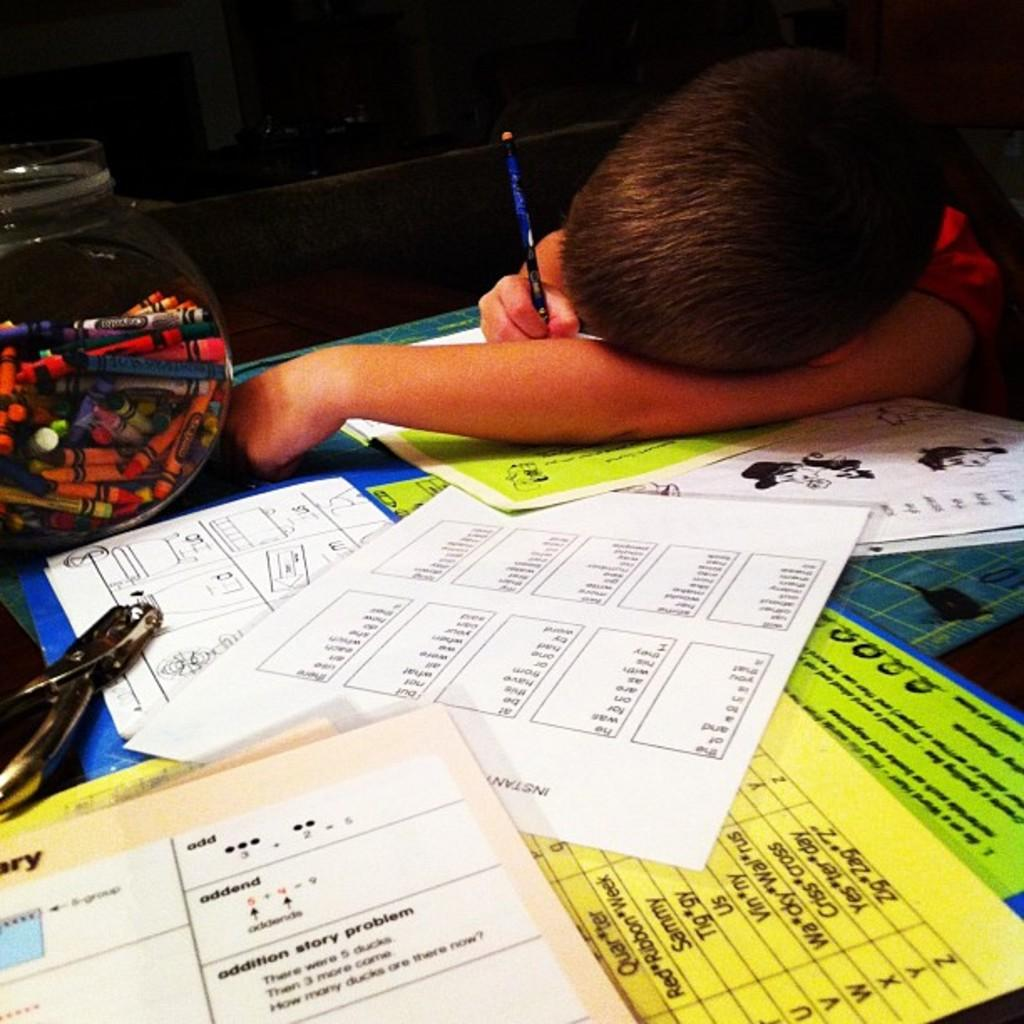What objects are in the glass bowl in the image? There are crayons in a glass bowl in the image. What else can be seen in the image besides the crayons? There are papers and a punching machine on the table in the image. What is the kid holding in the image? The kid is holding a pencil in the image. How is the kid positioned in relation to the papers? The kid is laying on the papers in the image. What type of zinc is present in the image? There is no zinc present in the image. What color is the skirt the kid is wearing in the image? The kid is not wearing a skirt in the image; they are laying on the papers while holding a pencil. 